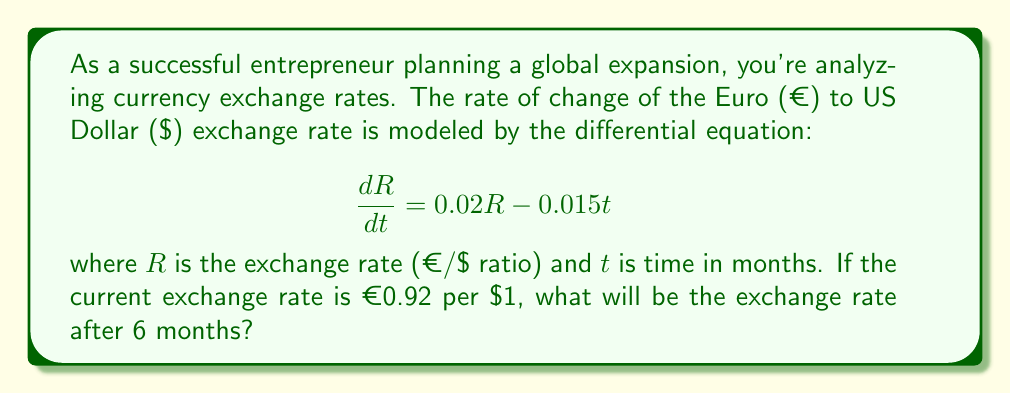Help me with this question. To solve this first-order linear differential equation, we'll follow these steps:

1) The general form of a first-order linear differential equation is:

   $$\frac{dy}{dx} + P(x)y = Q(x)$$

   In our case, $\frac{dR}{dt} + (-0.02)R = -0.015t$

2) The integrating factor is $e^{\int P(x)dx}$. Here, $P(t) = -0.02$, so:

   Integrating factor = $e^{\int -0.02 dt} = e^{-0.02t}$

3) Multiply both sides of the equation by the integrating factor:

   $e^{-0.02t}\frac{dR}{dt} + e^{-0.02t}(-0.02)R = e^{-0.02t}(-0.015t)$

4) The left side is now the derivative of $Re^{-0.02t}$:

   $\frac{d}{dt}(Re^{-0.02t}) = -0.015te^{-0.02t}$

5) Integrate both sides:

   $Re^{-0.02t} = -0.015\int te^{-0.02t}dt$

6) Using integration by parts:

   $Re^{-0.02t} = -0.015[-50te^{-0.02t} - 2500e^{-0.02t}] + C$

7) Simplify:

   $R = 0.75t + 37.5 + Ce^{0.02t}$

8) Use the initial condition: $R = 0.92$ when $t = 0$:

   $0.92 = 37.5 + C$
   $C = -36.58$

9) The particular solution is:

   $R = 0.75t + 37.5 - 36.58e^{0.02t}$

10) Calculate $R$ when $t = 6$:

    $R = 0.75(6) + 37.5 - 36.58e^{0.02(6)}$
    $R = 4.5 + 37.5 - 36.58(1.1275)$
    $R = 42 - 41.24 = 0.76$
Answer: The exchange rate after 6 months will be approximately €0.76 per $1. 